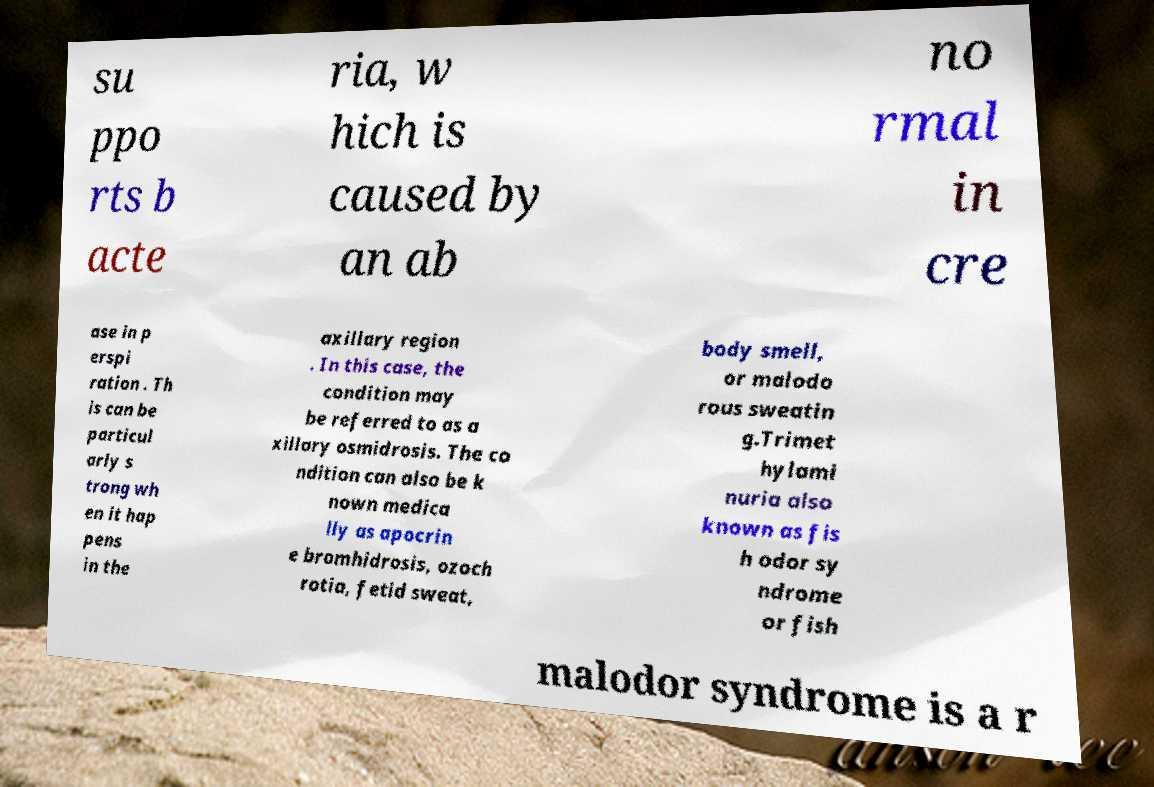Please identify and transcribe the text found in this image. su ppo rts b acte ria, w hich is caused by an ab no rmal in cre ase in p erspi ration . Th is can be particul arly s trong wh en it hap pens in the axillary region . In this case, the condition may be referred to as a xillary osmidrosis. The co ndition can also be k nown medica lly as apocrin e bromhidrosis, ozoch rotia, fetid sweat, body smell, or malodo rous sweatin g.Trimet hylami nuria also known as fis h odor sy ndrome or fish malodor syndrome is a r 